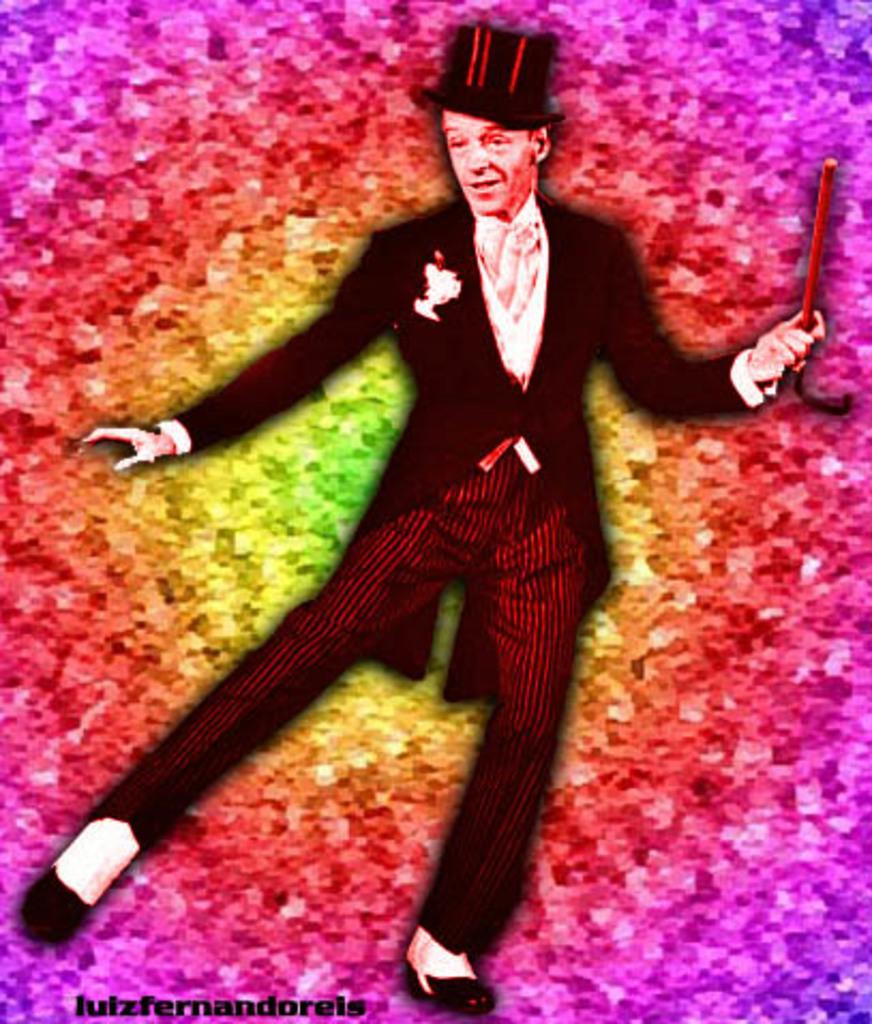What is the main subject of the image? There is a person in the image. Can you describe the person's attire? The person is wearing clothes and a hat. What can be observed about the background of the image? The background of the image is colorful. What is the person holding in their hand? The person is holding a stick in their hand. What date is marked on the calendar in the image? There is no calendar present in the image. Can you describe the fowl that is perched on the person's shoulder in the image? There is no fowl present in the image. 